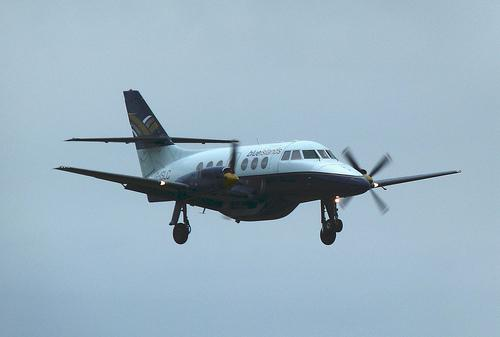Question: what is the color of the plane?
Choices:
A. Blue.
B. Silver.
C. White.
D. Grey.
Answer with the letter. Answer: C 